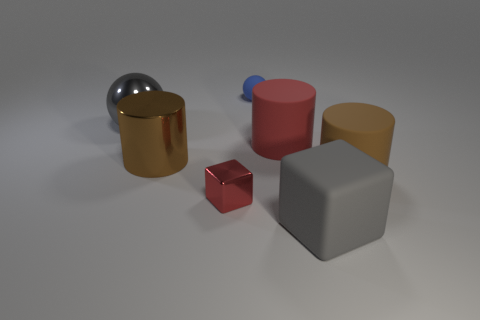What is the material of the gray sphere that is the same size as the brown matte object?
Keep it short and to the point. Metal. There is a brown cylinder that is to the right of the shiny thing that is in front of the big brown thing on the left side of the tiny blue thing; what is its size?
Your answer should be very brief. Large. How many other objects are there of the same material as the small blue sphere?
Provide a short and direct response. 3. What size is the shiny cylinder on the left side of the rubber cube?
Give a very brief answer. Large. How many objects are both on the left side of the gray rubber thing and in front of the brown rubber cylinder?
Keep it short and to the point. 1. What material is the gray thing that is to the left of the cube that is right of the red block?
Offer a terse response. Metal. What is the material of the other thing that is the same shape as the small red thing?
Make the answer very short. Rubber. Are any big brown matte blocks visible?
Offer a very short reply. No. There is a large brown thing that is made of the same material as the tiny red thing; what shape is it?
Provide a short and direct response. Cylinder. There is a cylinder that is on the left side of the small sphere; what material is it?
Offer a terse response. Metal. 